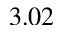<formula> <loc_0><loc_0><loc_500><loc_500>3 . 0 2</formula> 